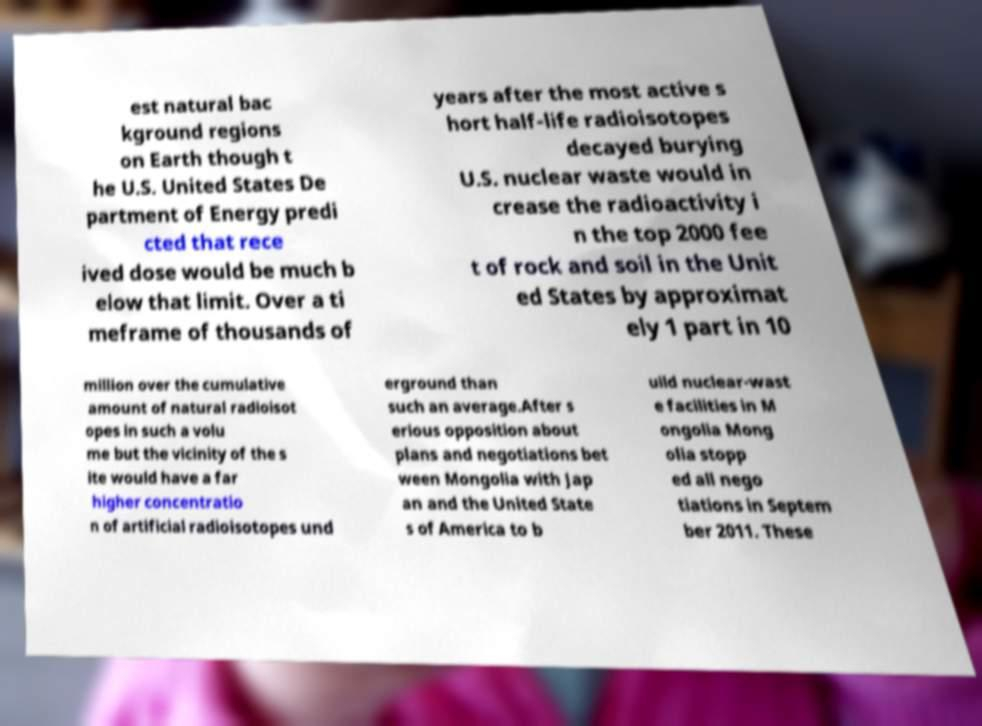Can you accurately transcribe the text from the provided image for me? est natural bac kground regions on Earth though t he U.S. United States De partment of Energy predi cted that rece ived dose would be much b elow that limit. Over a ti meframe of thousands of years after the most active s hort half-life radioisotopes decayed burying U.S. nuclear waste would in crease the radioactivity i n the top 2000 fee t of rock and soil in the Unit ed States by approximat ely 1 part in 10 million over the cumulative amount of natural radioisot opes in such a volu me but the vicinity of the s ite would have a far higher concentratio n of artificial radioisotopes und erground than such an average.After s erious opposition about plans and negotiations bet ween Mongolia with Jap an and the United State s of America to b uild nuclear-wast e facilities in M ongolia Mong olia stopp ed all nego tiations in Septem ber 2011. These 